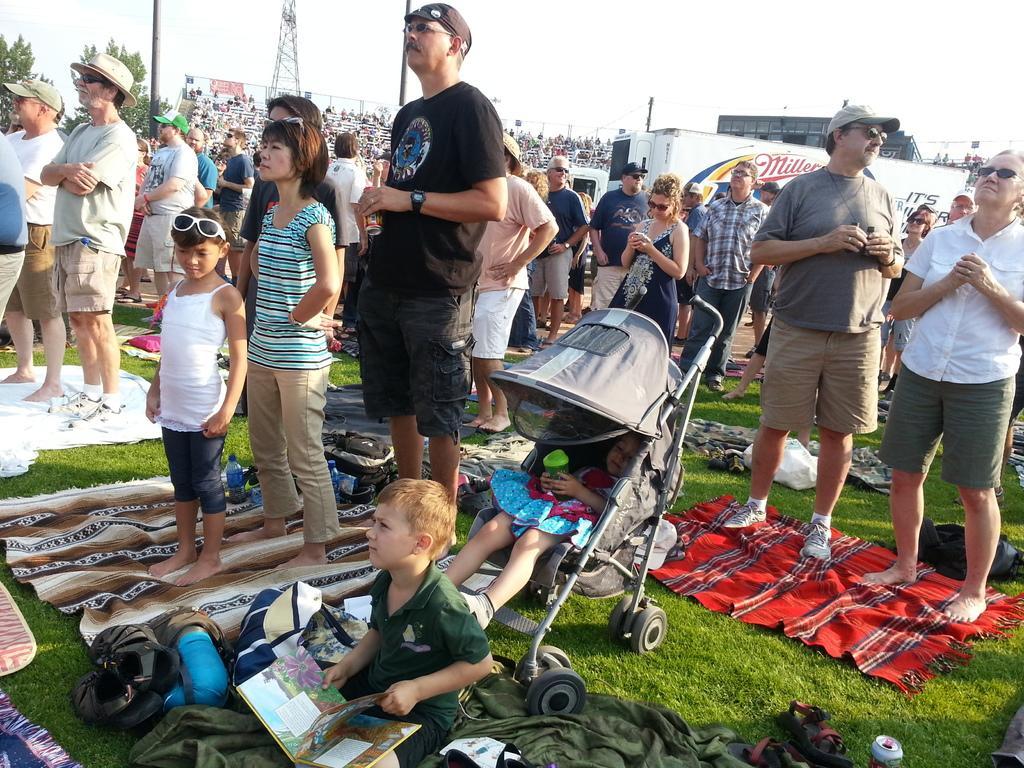Please provide a concise description of this image. In this picture, we can see a few people standing, a child is sitting and another child in the baby trolley, we can see the ground with grass and some objects like mats, bags, tin, and we can see some poles, containers, building with windows, towers and the sky. 